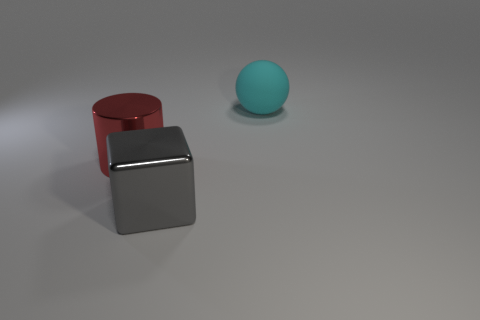Add 3 cyan matte things. How many objects exist? 6 Subtract all balls. How many objects are left? 2 Add 2 big cylinders. How many big cylinders are left? 3 Add 3 green cylinders. How many green cylinders exist? 3 Subtract 1 cyan balls. How many objects are left? 2 Subtract all gray balls. Subtract all gray shiny cubes. How many objects are left? 2 